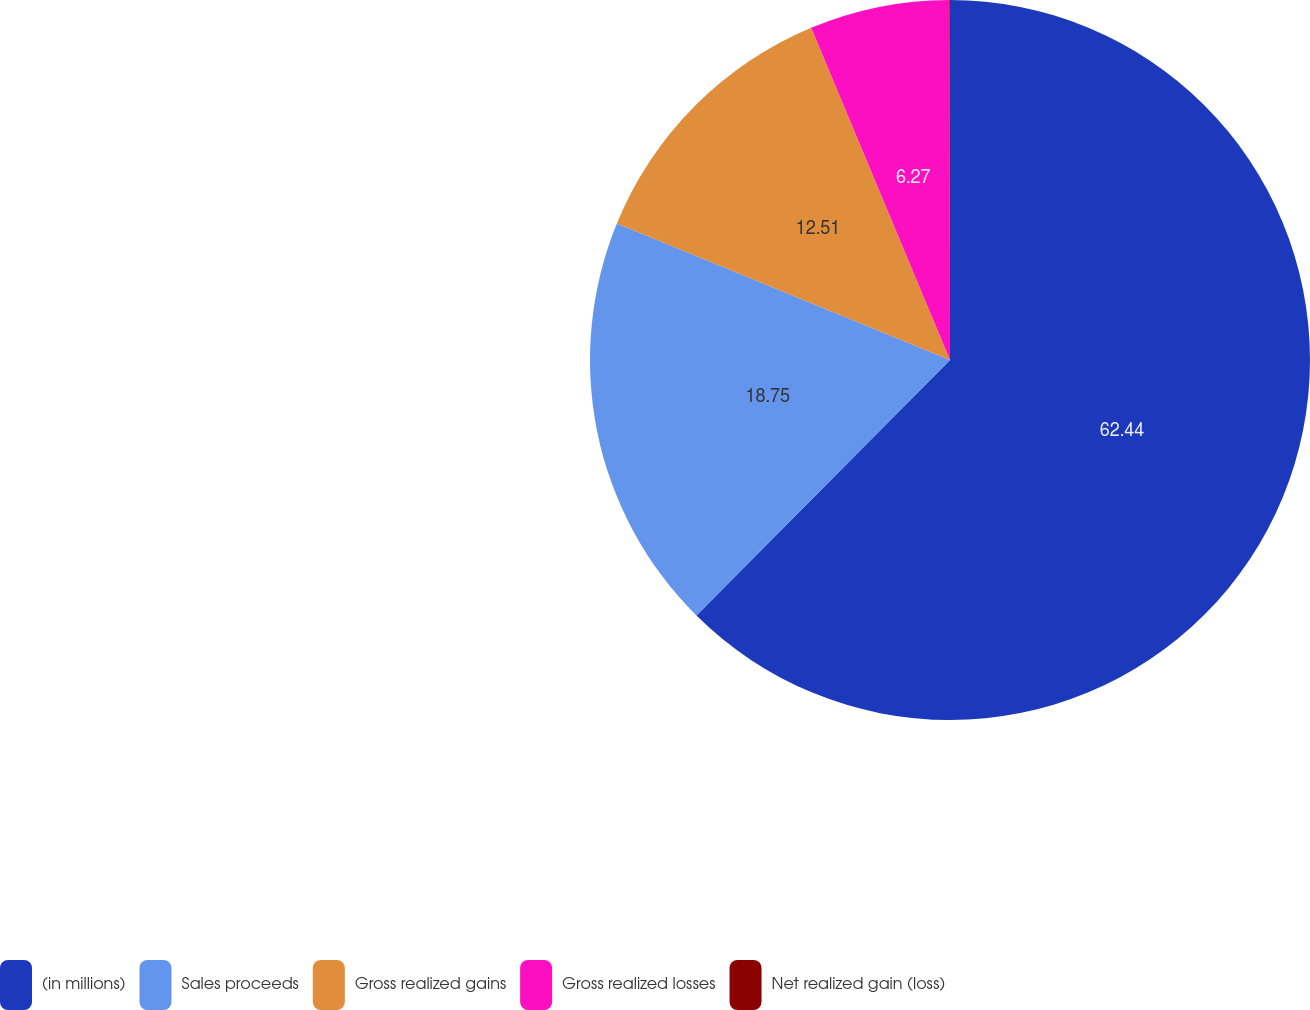Convert chart. <chart><loc_0><loc_0><loc_500><loc_500><pie_chart><fcel>(in millions)<fcel>Sales proceeds<fcel>Gross realized gains<fcel>Gross realized losses<fcel>Net realized gain (loss)<nl><fcel>62.43%<fcel>18.75%<fcel>12.51%<fcel>6.27%<fcel>0.03%<nl></chart> 